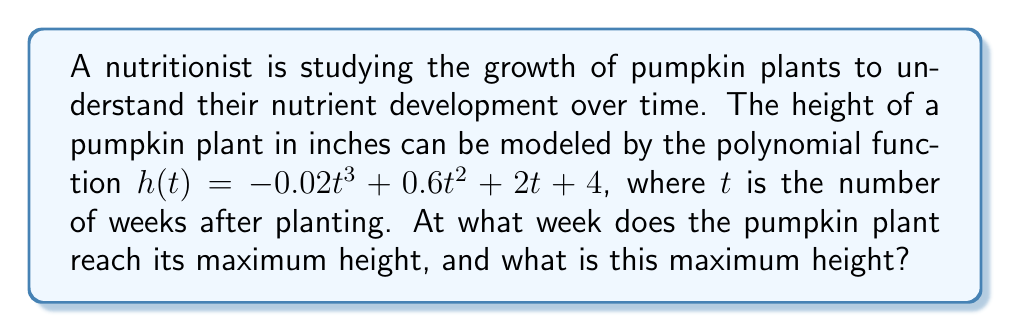Solve this math problem. To find the maximum height of the pumpkin plant, we need to follow these steps:

1) First, we need to find the derivative of the height function $h(t)$:
   $$h'(t) = -0.06t^2 + 1.2t + 2$$

2) To find the critical points, we set $h'(t) = 0$ and solve for $t$:
   $$-0.06t^2 + 1.2t + 2 = 0$$

3) This is a quadratic equation. We can solve it using the quadratic formula:
   $$t = \frac{-b \pm \sqrt{b^2 - 4ac}}{2a}$$
   where $a = -0.06$, $b = 1.2$, and $c = 2$

4) Plugging in these values:
   $$t = \frac{-1.2 \pm \sqrt{1.44 - 4(-0.06)(2)}}{2(-0.06)}$$
   $$= \frac{-1.2 \pm \sqrt{1.44 + 0.48}}{-0.12}$$
   $$= \frac{-1.2 \pm \sqrt{1.92}}{-0.12}$$
   $$= \frac{-1.2 \pm 1.3856}{-0.12}$$

5) This gives us two solutions:
   $$t_1 = \frac{-1.2 + 1.3856}{-0.12} \approx 1.55$$
   $$t_2 = \frac{-1.2 - 1.3856}{-0.12} \approx 21.55$$

6) Since we're dealing with plant growth, we'll consider the positive solution: $t \approx 21.55$ weeks.

7) To confirm this is a maximum (not a minimum), we can check the second derivative:
   $$h''(t) = -0.12t + 1.2$$
   At $t = 21.55$, $h''(21.55) = -1.386 < 0$, confirming it's a maximum.

8) To find the maximum height, we plug $t = 21.55$ into the original function:
   $$h(21.55) = -0.02(21.55)^3 + 0.6(21.55)^2 + 2(21.55) + 4 \approx 91.67$$ inches

Therefore, the pumpkin plant reaches its maximum height of approximately 91.67 inches at about 21.55 weeks after planting.
Answer: 21.55 weeks; 91.67 inches 